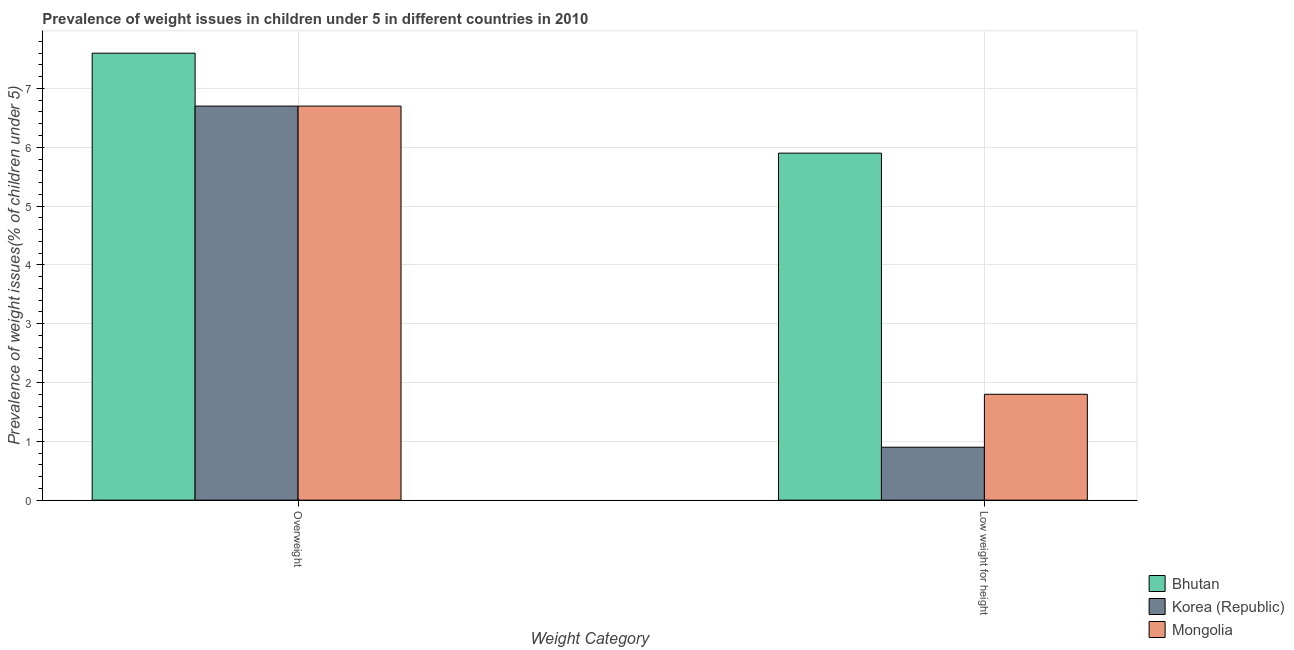How many different coloured bars are there?
Your answer should be very brief. 3. How many groups of bars are there?
Give a very brief answer. 2. Are the number of bars per tick equal to the number of legend labels?
Ensure brevity in your answer.  Yes. How many bars are there on the 2nd tick from the left?
Make the answer very short. 3. What is the label of the 1st group of bars from the left?
Ensure brevity in your answer.  Overweight. What is the percentage of underweight children in Korea (Republic)?
Offer a terse response. 0.9. Across all countries, what is the maximum percentage of overweight children?
Offer a terse response. 7.6. Across all countries, what is the minimum percentage of underweight children?
Your answer should be very brief. 0.9. In which country was the percentage of overweight children maximum?
Offer a terse response. Bhutan. In which country was the percentage of underweight children minimum?
Provide a short and direct response. Korea (Republic). What is the total percentage of underweight children in the graph?
Your answer should be very brief. 8.6. What is the difference between the percentage of underweight children in Bhutan and that in Mongolia?
Provide a short and direct response. 4.1. What is the difference between the percentage of overweight children in Mongolia and the percentage of underweight children in Korea (Republic)?
Give a very brief answer. 5.8. What is the average percentage of overweight children per country?
Keep it short and to the point. 7. What is the difference between the percentage of underweight children and percentage of overweight children in Mongolia?
Ensure brevity in your answer.  -4.9. In how many countries, is the percentage of underweight children greater than 5.6 %?
Keep it short and to the point. 1. What is the ratio of the percentage of underweight children in Mongolia to that in Bhutan?
Ensure brevity in your answer.  0.31. Is the percentage of underweight children in Mongolia less than that in Korea (Republic)?
Your answer should be very brief. No. In how many countries, is the percentage of overweight children greater than the average percentage of overweight children taken over all countries?
Ensure brevity in your answer.  1. What does the 1st bar from the left in Overweight represents?
Make the answer very short. Bhutan. What does the 1st bar from the right in Low weight for height represents?
Keep it short and to the point. Mongolia. How many bars are there?
Offer a terse response. 6. What is the difference between two consecutive major ticks on the Y-axis?
Give a very brief answer. 1. Does the graph contain any zero values?
Offer a very short reply. No. How many legend labels are there?
Make the answer very short. 3. What is the title of the graph?
Your response must be concise. Prevalence of weight issues in children under 5 in different countries in 2010. Does "Guinea" appear as one of the legend labels in the graph?
Provide a short and direct response. No. What is the label or title of the X-axis?
Your answer should be compact. Weight Category. What is the label or title of the Y-axis?
Make the answer very short. Prevalence of weight issues(% of children under 5). What is the Prevalence of weight issues(% of children under 5) of Bhutan in Overweight?
Your answer should be compact. 7.6. What is the Prevalence of weight issues(% of children under 5) of Korea (Republic) in Overweight?
Offer a terse response. 6.7. What is the Prevalence of weight issues(% of children under 5) of Mongolia in Overweight?
Make the answer very short. 6.7. What is the Prevalence of weight issues(% of children under 5) in Bhutan in Low weight for height?
Give a very brief answer. 5.9. What is the Prevalence of weight issues(% of children under 5) of Korea (Republic) in Low weight for height?
Give a very brief answer. 0.9. What is the Prevalence of weight issues(% of children under 5) of Mongolia in Low weight for height?
Provide a short and direct response. 1.8. Across all Weight Category, what is the maximum Prevalence of weight issues(% of children under 5) in Bhutan?
Your answer should be compact. 7.6. Across all Weight Category, what is the maximum Prevalence of weight issues(% of children under 5) in Korea (Republic)?
Keep it short and to the point. 6.7. Across all Weight Category, what is the maximum Prevalence of weight issues(% of children under 5) in Mongolia?
Keep it short and to the point. 6.7. Across all Weight Category, what is the minimum Prevalence of weight issues(% of children under 5) of Bhutan?
Ensure brevity in your answer.  5.9. Across all Weight Category, what is the minimum Prevalence of weight issues(% of children under 5) in Korea (Republic)?
Your answer should be very brief. 0.9. Across all Weight Category, what is the minimum Prevalence of weight issues(% of children under 5) in Mongolia?
Make the answer very short. 1.8. What is the total Prevalence of weight issues(% of children under 5) in Mongolia in the graph?
Keep it short and to the point. 8.5. What is the difference between the Prevalence of weight issues(% of children under 5) in Korea (Republic) in Overweight and that in Low weight for height?
Offer a terse response. 5.8. What is the difference between the Prevalence of weight issues(% of children under 5) in Mongolia in Overweight and that in Low weight for height?
Provide a short and direct response. 4.9. What is the average Prevalence of weight issues(% of children under 5) in Bhutan per Weight Category?
Give a very brief answer. 6.75. What is the average Prevalence of weight issues(% of children under 5) in Mongolia per Weight Category?
Your response must be concise. 4.25. What is the difference between the Prevalence of weight issues(% of children under 5) of Bhutan and Prevalence of weight issues(% of children under 5) of Korea (Republic) in Overweight?
Provide a succinct answer. 0.9. What is the difference between the Prevalence of weight issues(% of children under 5) in Bhutan and Prevalence of weight issues(% of children under 5) in Mongolia in Low weight for height?
Provide a short and direct response. 4.1. What is the ratio of the Prevalence of weight issues(% of children under 5) of Bhutan in Overweight to that in Low weight for height?
Offer a very short reply. 1.29. What is the ratio of the Prevalence of weight issues(% of children under 5) in Korea (Republic) in Overweight to that in Low weight for height?
Offer a terse response. 7.44. What is the ratio of the Prevalence of weight issues(% of children under 5) in Mongolia in Overweight to that in Low weight for height?
Keep it short and to the point. 3.72. What is the difference between the highest and the second highest Prevalence of weight issues(% of children under 5) of Korea (Republic)?
Provide a short and direct response. 5.8. What is the difference between the highest and the second highest Prevalence of weight issues(% of children under 5) of Mongolia?
Your response must be concise. 4.9. 